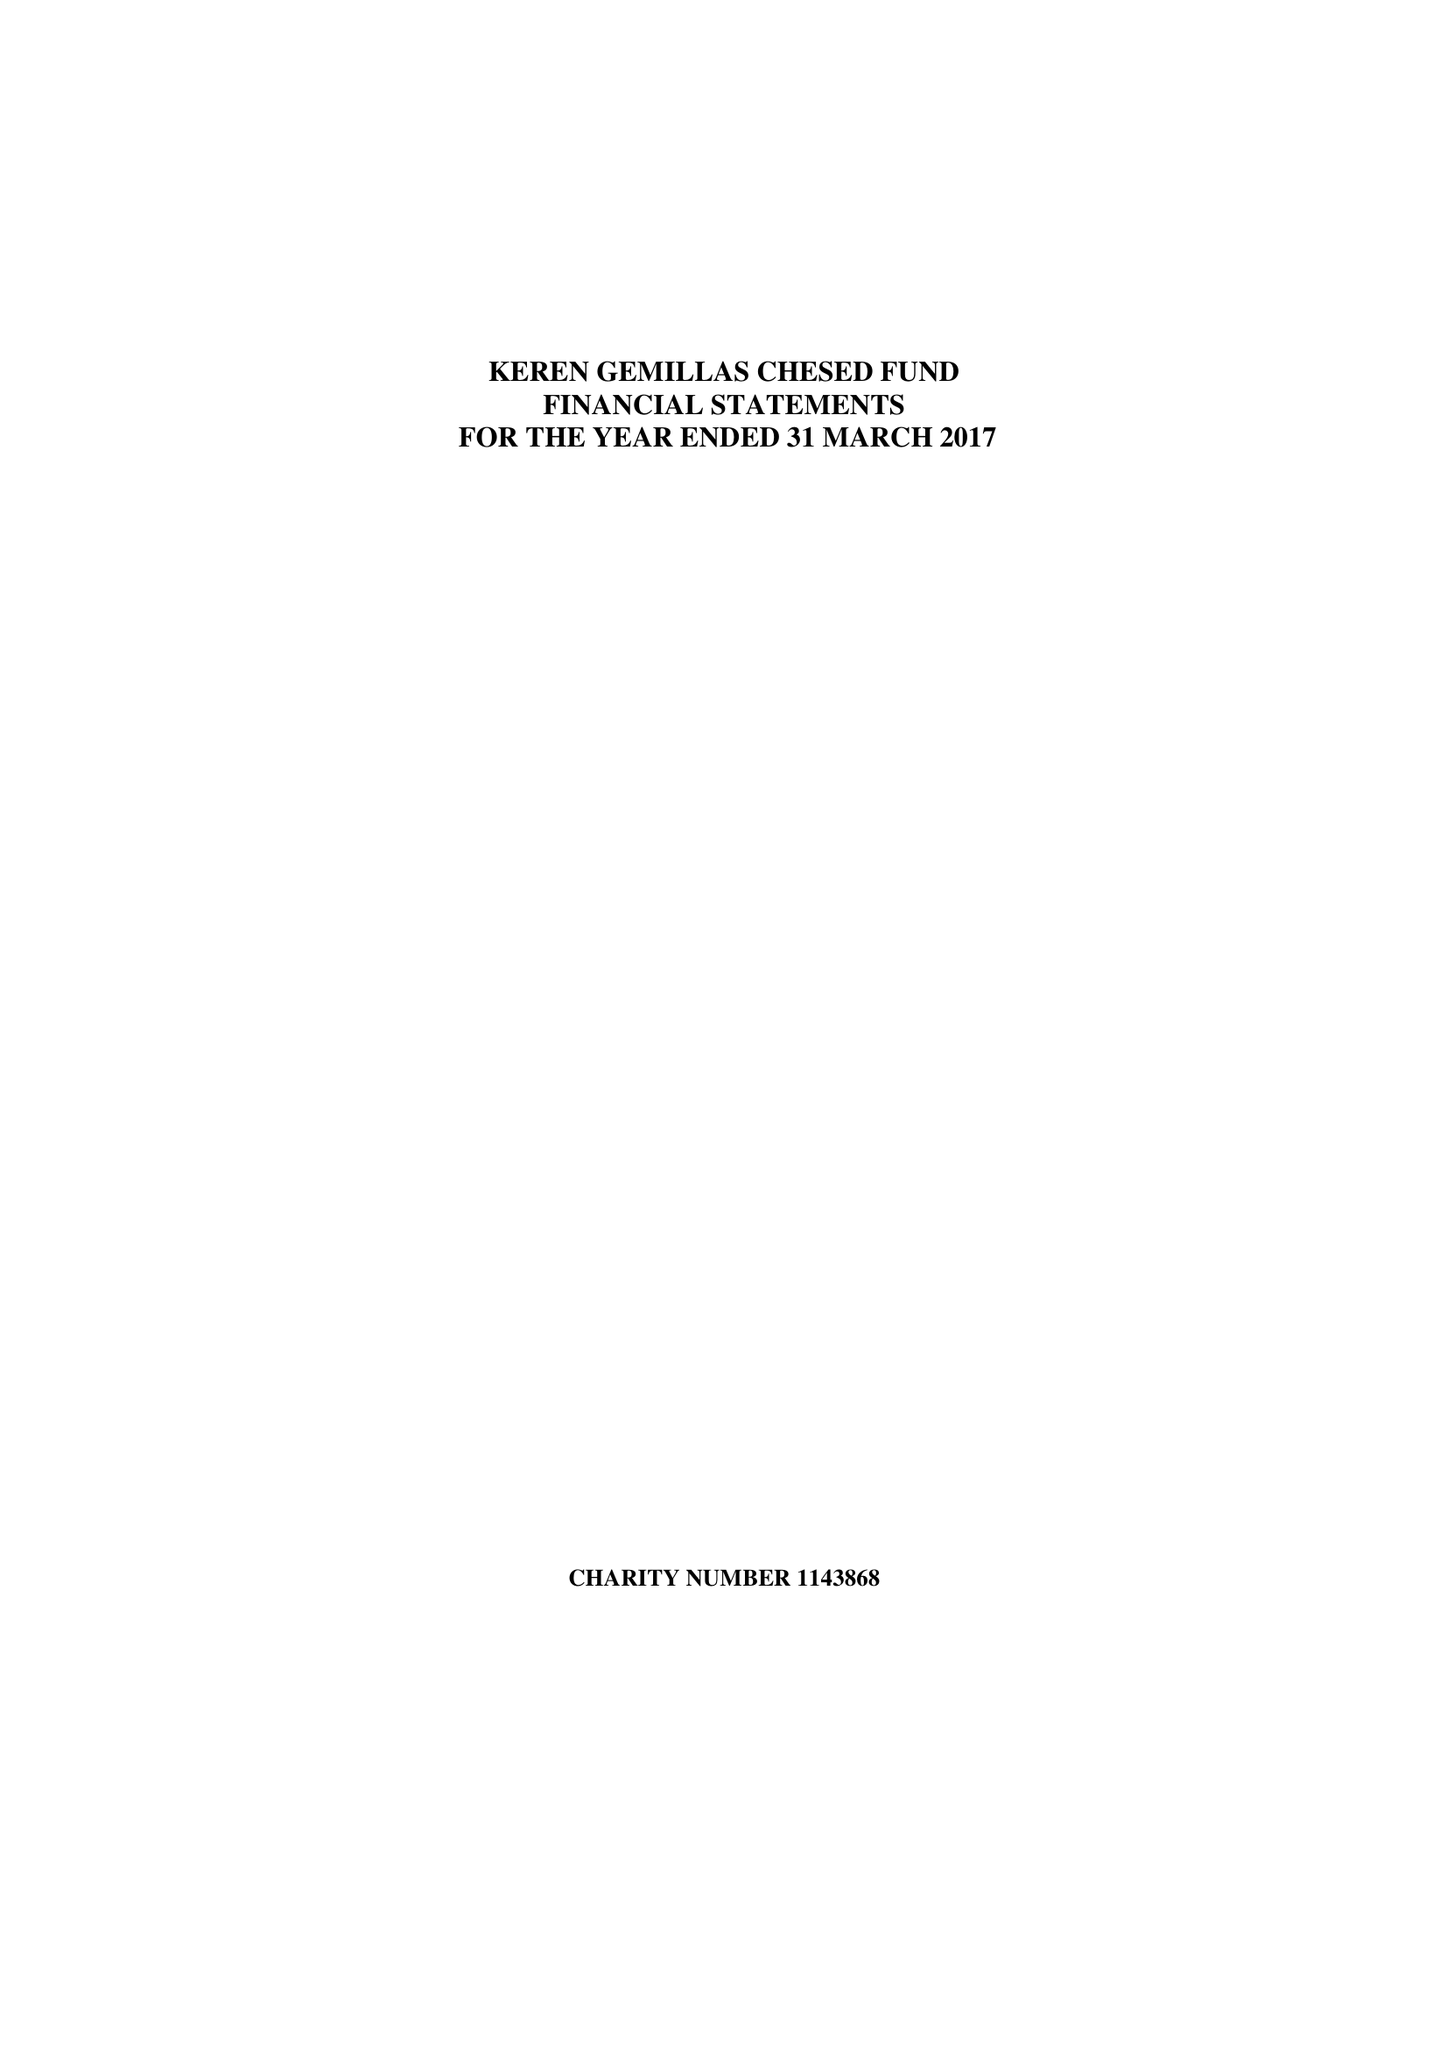What is the value for the address__postcode?
Answer the question using a single word or phrase. M7 4HQ 